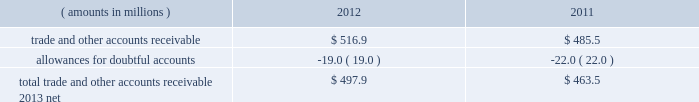Notes to consolidated financial statements ( continued ) fair value measurements the fasb issued updated authoritative guidance in may 2011 to amend fair value measurements and related disclosures ; the guidance became effective for snap-on at the beginning of its 2012 fiscal year .
This guidance relates to a major convergence project of the fasb and the international accounting standards board to improve international financial reporting standards ( 201cifrs 201d ) and u.s .
Gaap .
This guidance resulted in a consistent definition of fair value and common requirements for measurement of and disclosure about fair value between ifrs and u.s .
Gaap .
The guidance also changed some fair value measurement principles and enhanced disclosure requirements related to activities in level 3 of the fair value hierarchy .
The adoption of this updated authoritative guidance had no impact on the company 2019s consolidated financial statements .
Disclosures relating to comprehensive income the fasb issued updated authoritative guidance in june 2011 to amend the presentation of comprehensive income in financial statements .
The fasb also issued an accounting standards update in december 2011 that indefinitely deferred certain financial statement presentation provisions contained in its original june 2011 guidance .
The guidance , which became effective for snap-on on a retrospective basis at the beginning of its 2012 fiscal year , gives companies the option to present other comprehensive income in either a single continuous statement or in two separate but consecutive statements .
Under both alternatives , companies are required to annually present each component of comprehensive income .
The adoption of this updated authoritative guidance impacted the presentation of the company 2019s consolidated statements of comprehensive income , but it did not change the items that must be reported in other comprehensive income or when an item of other comprehensive income must be reclassified to net income .
Note 2 : acquisitions snap-on acquired a 60% ( 60 % ) interest in snap-on asia manufacturing ( zhejiang ) co .
Ltd .
( 201cxiaoshan 201d ) ( formerly known as wanda snap-on ( zhejiang ) co .
Ltd. ) , the company 2019s tool manufacturing operation in xiaoshan , china , in 2008 .
Snap-on acquired the remaining 40% ( 40 % ) redeemable noncontrolling interest in xiaoshan in april 2010 for a purchase price of $ 7.7 million and $ 0.1 million of transaction costs .
Note 3 : receivables trade and other accounts receivable snap-on 2019s trade and other accounts receivable primarily arise from the sale of tools , diagnostics and equipment to a broad range of industrial and commercial customers and to snap-on 2019s independent franchise van channel on a non- extended-term basis with payment terms generally ranging from 30 to 120 days .
The components of snap-on 2019s trade and other accounts receivable as of 2012 and 2011 year end are as follows : ( amounts in millions ) 2012 2011 .
Finance and contract receivables soc originates extended-term finance and contract receivables on sales of snap-on product sold through the u.s .
Franchisee and customer network and to snap-on 2019s industrial and other customers ; snap-on 2019s foreign finance subsidiaries provide similar financing internationally .
Interest income on finance and contract receivables is included in 201cfinancial services revenue 201d on the accompanying consolidated statements of earnings .
74 snap-on incorporated .
What is the change in cash flow from operating activities due to the changes in accounts receivable? 
Computations: (485.5 - 516.9)
Answer: -31.4. Notes to consolidated financial statements ( continued ) fair value measurements the fasb issued updated authoritative guidance in may 2011 to amend fair value measurements and related disclosures ; the guidance became effective for snap-on at the beginning of its 2012 fiscal year .
This guidance relates to a major convergence project of the fasb and the international accounting standards board to improve international financial reporting standards ( 201cifrs 201d ) and u.s .
Gaap .
This guidance resulted in a consistent definition of fair value and common requirements for measurement of and disclosure about fair value between ifrs and u.s .
Gaap .
The guidance also changed some fair value measurement principles and enhanced disclosure requirements related to activities in level 3 of the fair value hierarchy .
The adoption of this updated authoritative guidance had no impact on the company 2019s consolidated financial statements .
Disclosures relating to comprehensive income the fasb issued updated authoritative guidance in june 2011 to amend the presentation of comprehensive income in financial statements .
The fasb also issued an accounting standards update in december 2011 that indefinitely deferred certain financial statement presentation provisions contained in its original june 2011 guidance .
The guidance , which became effective for snap-on on a retrospective basis at the beginning of its 2012 fiscal year , gives companies the option to present other comprehensive income in either a single continuous statement or in two separate but consecutive statements .
Under both alternatives , companies are required to annually present each component of comprehensive income .
The adoption of this updated authoritative guidance impacted the presentation of the company 2019s consolidated statements of comprehensive income , but it did not change the items that must be reported in other comprehensive income or when an item of other comprehensive income must be reclassified to net income .
Note 2 : acquisitions snap-on acquired a 60% ( 60 % ) interest in snap-on asia manufacturing ( zhejiang ) co .
Ltd .
( 201cxiaoshan 201d ) ( formerly known as wanda snap-on ( zhejiang ) co .
Ltd. ) , the company 2019s tool manufacturing operation in xiaoshan , china , in 2008 .
Snap-on acquired the remaining 40% ( 40 % ) redeemable noncontrolling interest in xiaoshan in april 2010 for a purchase price of $ 7.7 million and $ 0.1 million of transaction costs .
Note 3 : receivables trade and other accounts receivable snap-on 2019s trade and other accounts receivable primarily arise from the sale of tools , diagnostics and equipment to a broad range of industrial and commercial customers and to snap-on 2019s independent franchise van channel on a non- extended-term basis with payment terms generally ranging from 30 to 120 days .
The components of snap-on 2019s trade and other accounts receivable as of 2012 and 2011 year end are as follows : ( amounts in millions ) 2012 2011 .
Finance and contract receivables soc originates extended-term finance and contract receivables on sales of snap-on product sold through the u.s .
Franchisee and customer network and to snap-on 2019s industrial and other customers ; snap-on 2019s foreign finance subsidiaries provide similar financing internationally .
Interest income on finance and contract receivables is included in 201cfinancial services revenue 201d on the accompanying consolidated statements of earnings .
74 snap-on incorporated .
What portion for the trade and other accounts receivable is classified as part of the allowances for doubtful accounts? 
Computations: (19.0 / 516.9)
Answer: 0.03676. Notes to consolidated financial statements ( continued ) fair value measurements the fasb issued updated authoritative guidance in may 2011 to amend fair value measurements and related disclosures ; the guidance became effective for snap-on at the beginning of its 2012 fiscal year .
This guidance relates to a major convergence project of the fasb and the international accounting standards board to improve international financial reporting standards ( 201cifrs 201d ) and u.s .
Gaap .
This guidance resulted in a consistent definition of fair value and common requirements for measurement of and disclosure about fair value between ifrs and u.s .
Gaap .
The guidance also changed some fair value measurement principles and enhanced disclosure requirements related to activities in level 3 of the fair value hierarchy .
The adoption of this updated authoritative guidance had no impact on the company 2019s consolidated financial statements .
Disclosures relating to comprehensive income the fasb issued updated authoritative guidance in june 2011 to amend the presentation of comprehensive income in financial statements .
The fasb also issued an accounting standards update in december 2011 that indefinitely deferred certain financial statement presentation provisions contained in its original june 2011 guidance .
The guidance , which became effective for snap-on on a retrospective basis at the beginning of its 2012 fiscal year , gives companies the option to present other comprehensive income in either a single continuous statement or in two separate but consecutive statements .
Under both alternatives , companies are required to annually present each component of comprehensive income .
The adoption of this updated authoritative guidance impacted the presentation of the company 2019s consolidated statements of comprehensive income , but it did not change the items that must be reported in other comprehensive income or when an item of other comprehensive income must be reclassified to net income .
Note 2 : acquisitions snap-on acquired a 60% ( 60 % ) interest in snap-on asia manufacturing ( zhejiang ) co .
Ltd .
( 201cxiaoshan 201d ) ( formerly known as wanda snap-on ( zhejiang ) co .
Ltd. ) , the company 2019s tool manufacturing operation in xiaoshan , china , in 2008 .
Snap-on acquired the remaining 40% ( 40 % ) redeemable noncontrolling interest in xiaoshan in april 2010 for a purchase price of $ 7.7 million and $ 0.1 million of transaction costs .
Note 3 : receivables trade and other accounts receivable snap-on 2019s trade and other accounts receivable primarily arise from the sale of tools , diagnostics and equipment to a broad range of industrial and commercial customers and to snap-on 2019s independent franchise van channel on a non- extended-term basis with payment terms generally ranging from 30 to 120 days .
The components of snap-on 2019s trade and other accounts receivable as of 2012 and 2011 year end are as follows : ( amounts in millions ) 2012 2011 .
Finance and contract receivables soc originates extended-term finance and contract receivables on sales of snap-on product sold through the u.s .
Franchisee and customer network and to snap-on 2019s industrial and other customers ; snap-on 2019s foreign finance subsidiaries provide similar financing internationally .
Interest income on finance and contract receivables is included in 201cfinancial services revenue 201d on the accompanying consolidated statements of earnings .
74 snap-on incorporated .
In 2012 what was the allowance for doubtful accounts? 
Computations: (19.0 / 516.9)
Answer: 0.03676. 